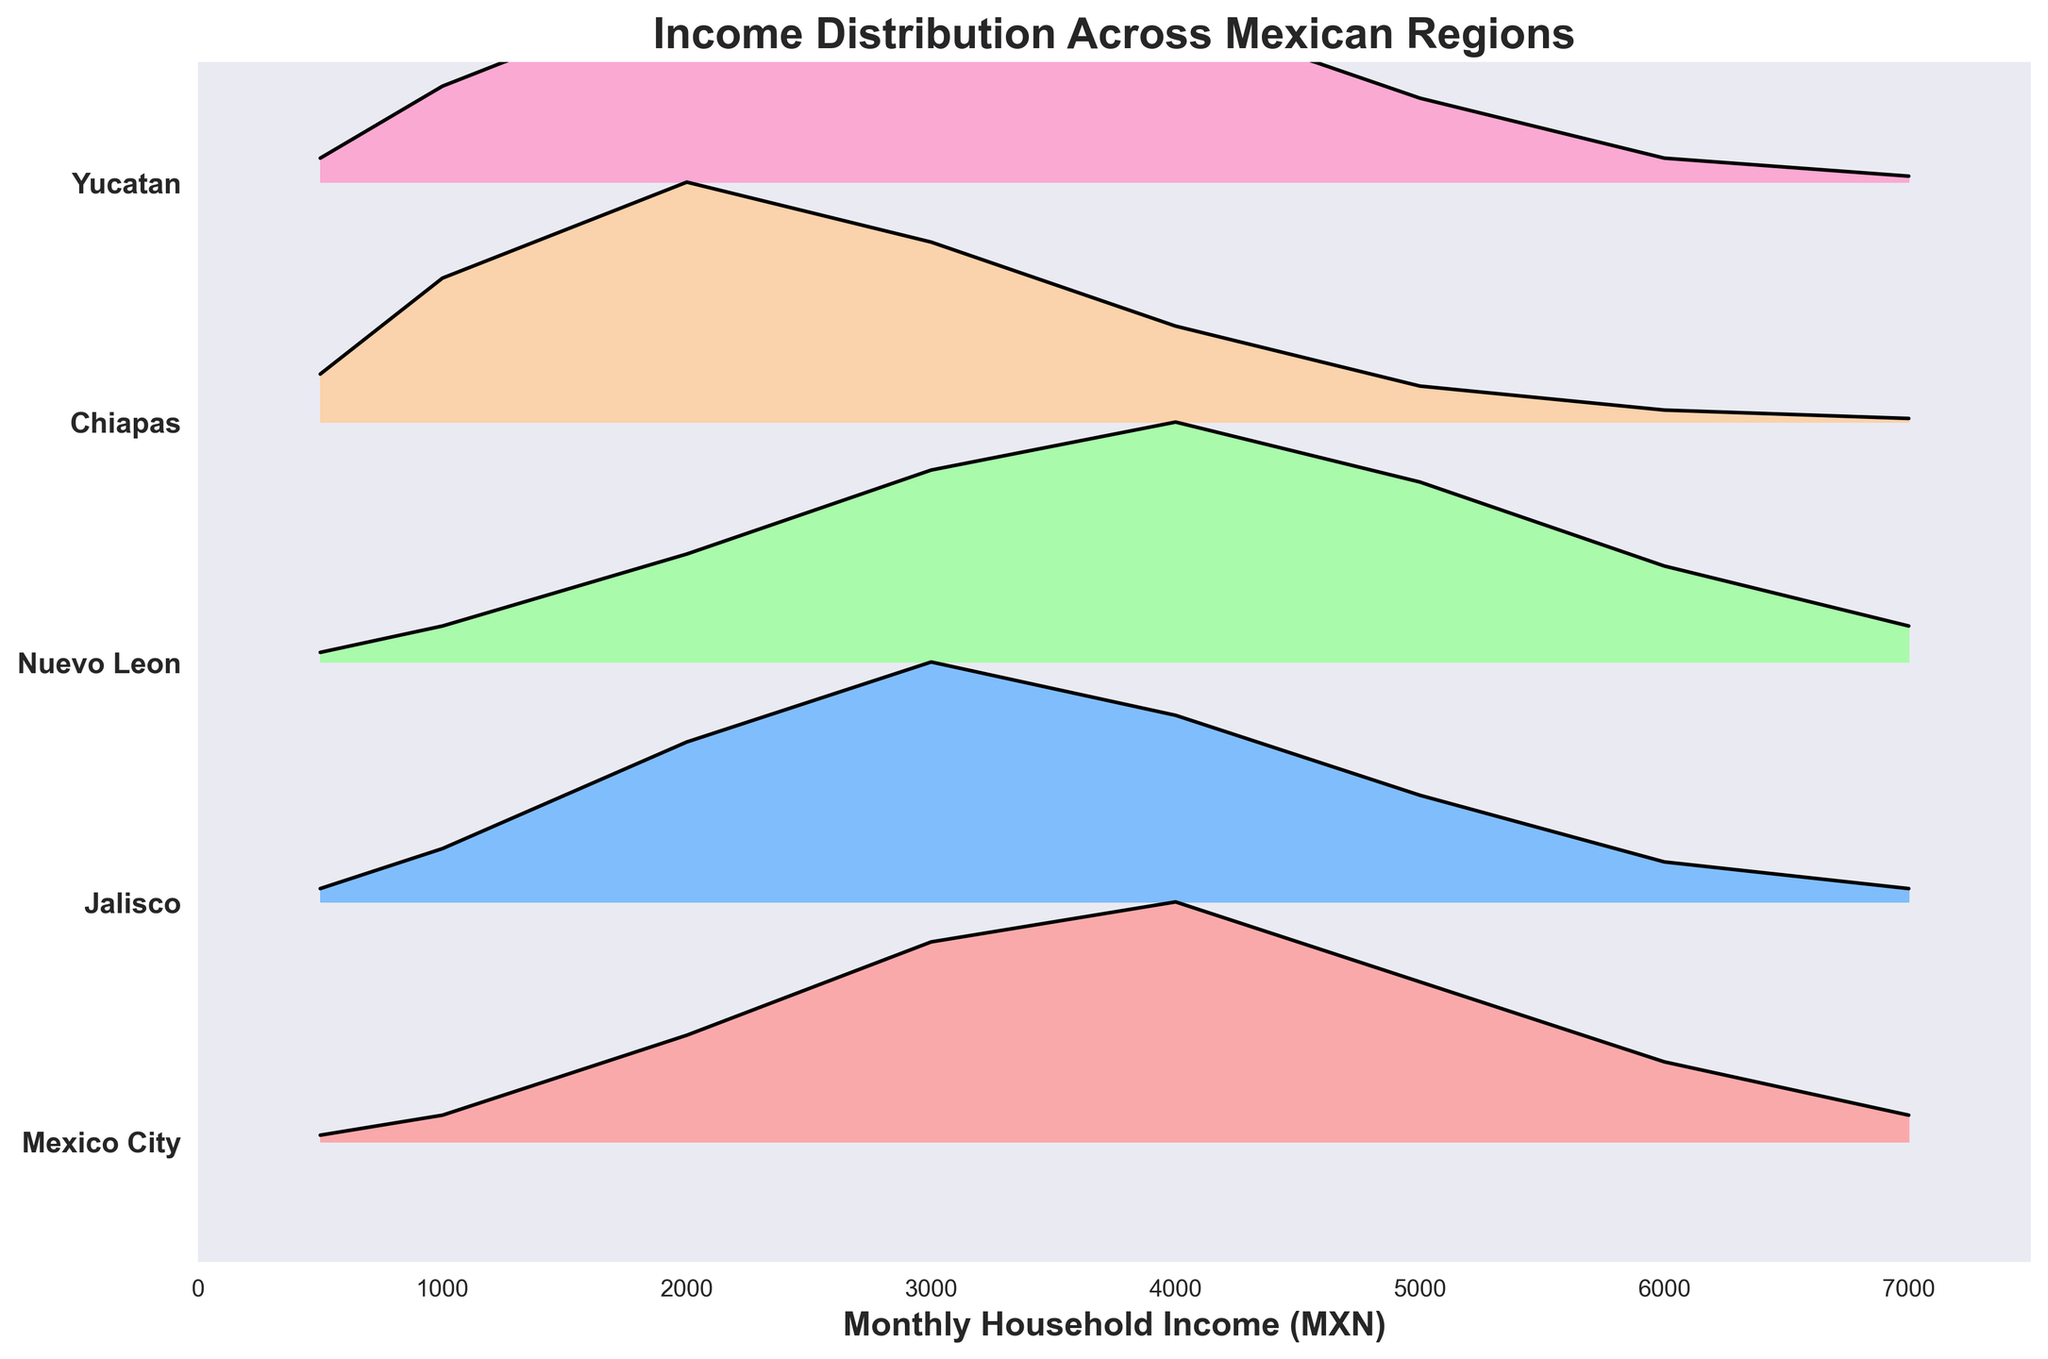What's the title of the plot? The title of the plot is displayed at the top and it reads "Income Distribution Across Mexican Regions".
Answer: Income Distribution Across Mexican Regions Which region shows the highest density for a monthly household income of 4000 MXN? To find this, we look for the peak in density at 4000 MXN on the plot. The highest peak at this income level is for Nuevo Leon.
Answer: Nuevo Leon What is the maximum density for Jalisco, and at which income level does it occur? The density values for Jalisco are plotted on the figure. The highest density value is 0.018 which occurs at 3000 MXN.
Answer: 0.0018, 3000 MXN Which region has the broadest income distribution? The region with the broadest income distribution will have the widest spread in the density curves. Mexico City has a broad distribution as the densities extend over a range of income levels from 500 to 7000 MXN.
Answer: Mexico City Between Mexico City and Chiapas, which region has a higher density at 5000 MXN? By observing the density at 5000 MXN for both regions, we see that Mexico City has a density of 0.0012 compared to Chiapas which has 0.0003. Therefore, Mexico City has a higher density at this income level.
Answer: Mexico City What is the total number of regions compared in this plot? The number of unique regions can be counted from the y-axis labels. The regions are Mexico City, Jalisco, Nuevo Leon, Chiapas, and Yucatan.
Answer: 5 At what income level does Yucatan reach its peak density? For Yucatan, the peak density value is 0.0020 and it occurs at an income level of 3000 MXN.
Answer: 3000 MXN Which region has the lowest density at 2000 MXN? To determine this, we compare the density values at 2000 MXN for all regions. The lowest density at this income level is Mexico City with a density of 0.0008.
Answer: Mexico City Is there any region that has a consistent increase in density up to a certain income level and then decreases? If so, which region and up to what income level? By examining the density curves, Chiapas shows a consistent increase in density up to 2000 MXN and then decreases afterwards.
Answer: Chiapas, 2000 MXN 